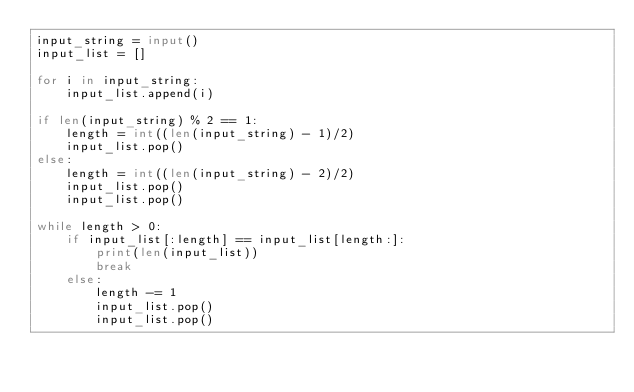Convert code to text. <code><loc_0><loc_0><loc_500><loc_500><_Python_>input_string = input()
input_list = []

for i in input_string:
    input_list.append(i)

if len(input_string) % 2 == 1:
    length = int((len(input_string) - 1)/2)
    input_list.pop()
else:
    length = int((len(input_string) - 2)/2)
    input_list.pop()
    input_list.pop()

while length > 0:
    if input_list[:length] == input_list[length:]:
        print(len(input_list))
        break
    else:
        length -= 1
        input_list.pop()
        input_list.pop()</code> 